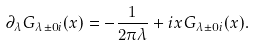<formula> <loc_0><loc_0><loc_500><loc_500>\partial _ { \lambda } G _ { \lambda \pm 0 i } ( x ) = - \frac { 1 } { 2 \pi \lambda } + i x G _ { \lambda \pm 0 i } ( x ) .</formula> 